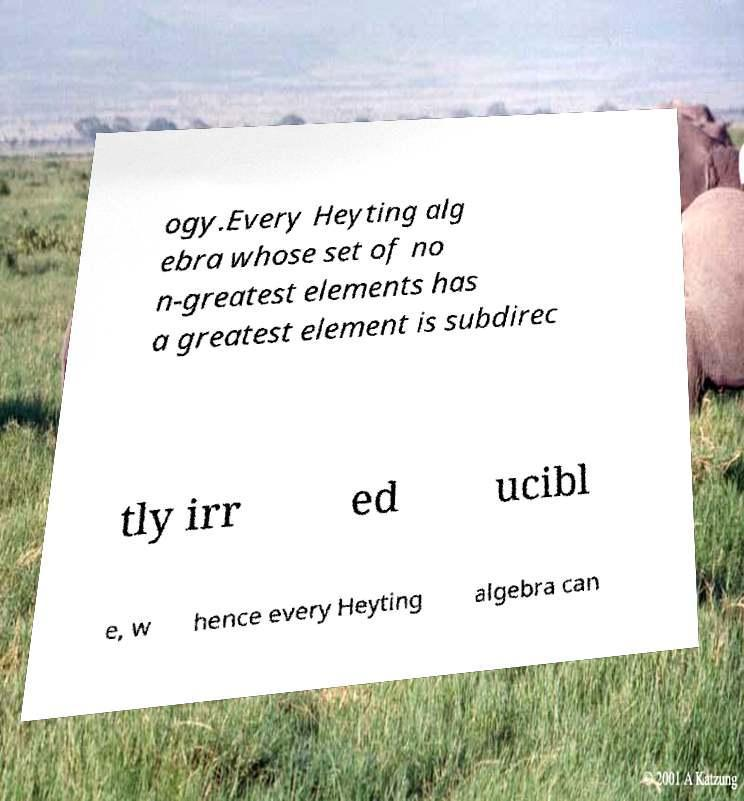What messages or text are displayed in this image? I need them in a readable, typed format. ogy.Every Heyting alg ebra whose set of no n-greatest elements has a greatest element is subdirec tly irr ed ucibl e, w hence every Heyting algebra can 